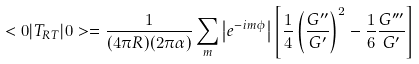Convert formula to latex. <formula><loc_0><loc_0><loc_500><loc_500>< 0 | T _ { R T } | 0 > = \frac { 1 } { ( 4 \pi R ) ( 2 \pi \alpha ) } \sum _ { m } \left | e ^ { - i m \phi } \right | \left [ \frac { 1 } { 4 } \left ( \frac { G ^ { \prime \prime } } { G ^ { \prime } } \right ) ^ { 2 } - \frac { 1 } { 6 } \frac { G ^ { \prime \prime \prime } } { G ^ { \prime } } \right ]</formula> 